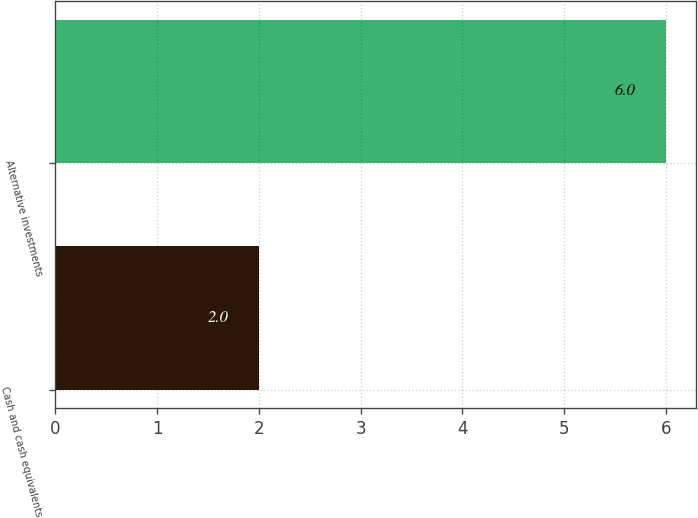Convert chart to OTSL. <chart><loc_0><loc_0><loc_500><loc_500><bar_chart><fcel>Cash and cash equivalents<fcel>Alternative investments<nl><fcel>2<fcel>6<nl></chart> 